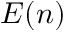Convert formula to latex. <formula><loc_0><loc_0><loc_500><loc_500>E ( n )</formula> 